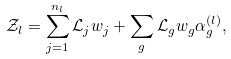<formula> <loc_0><loc_0><loc_500><loc_500>\mathcal { Z } _ { l } = \sum _ { j = 1 } ^ { n _ { l } } \mathcal { L } _ { j } w _ { j } + \sum _ { g } \mathcal { L } _ { g } w _ { g } \alpha ^ { ( l ) } _ { g } ,</formula> 